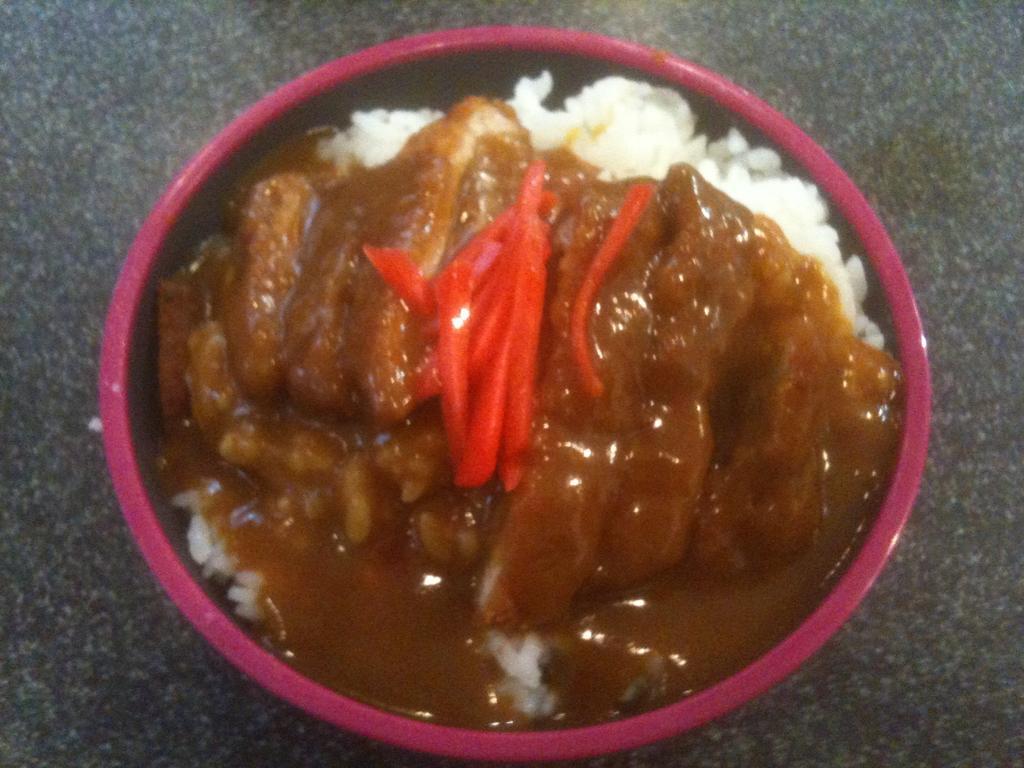Can you describe this image briefly? In the center of the picture there is a bowl, served with food. At the bottom it is floor. 